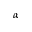Convert formula to latex. <formula><loc_0><loc_0><loc_500><loc_500>\alpha</formula> 